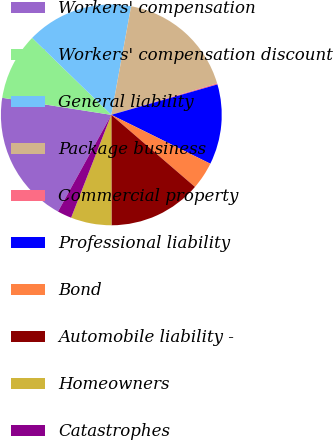<chart> <loc_0><loc_0><loc_500><loc_500><pie_chart><fcel>Workers' compensation<fcel>Workers' compensation discount<fcel>General liability<fcel>Package business<fcel>Commercial property<fcel>Professional liability<fcel>Bond<fcel>Automobile liability -<fcel>Homeowners<fcel>Catastrophes<nl><fcel>19.45%<fcel>9.81%<fcel>15.59%<fcel>17.52%<fcel>0.16%<fcel>11.74%<fcel>4.02%<fcel>13.66%<fcel>5.95%<fcel>2.09%<nl></chart> 